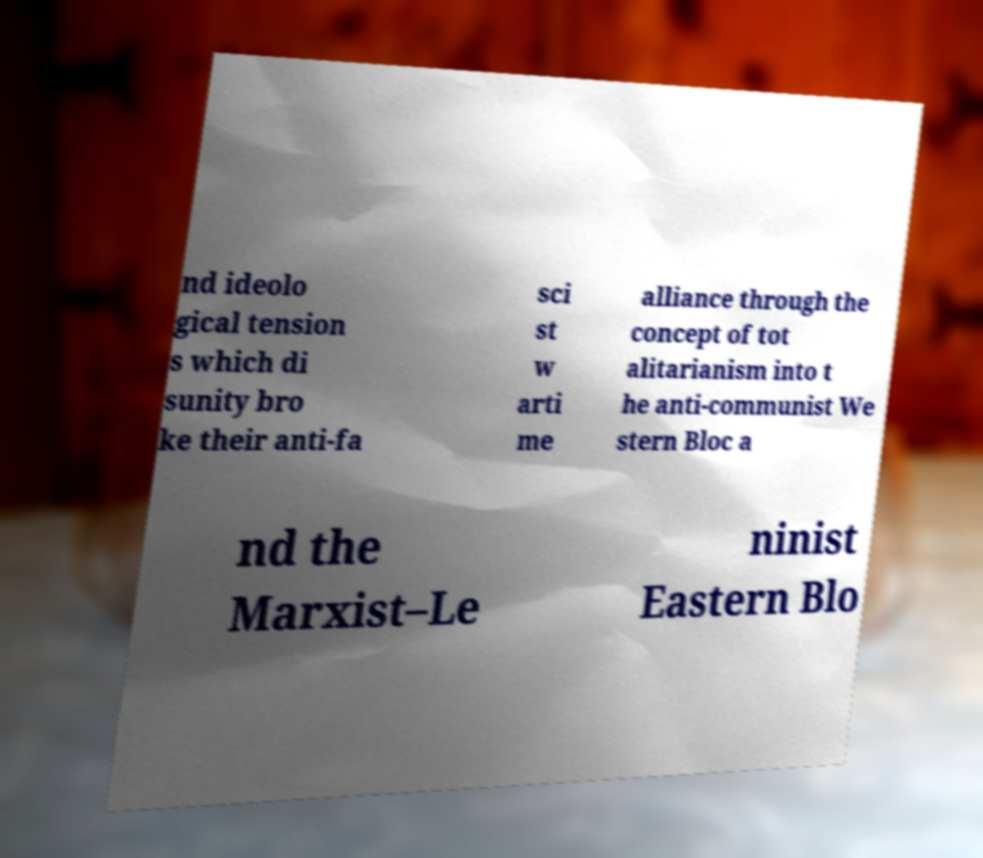I need the written content from this picture converted into text. Can you do that? nd ideolo gical tension s which di sunity bro ke their anti-fa sci st w arti me alliance through the concept of tot alitarianism into t he anti-communist We stern Bloc a nd the Marxist–Le ninist Eastern Blo 